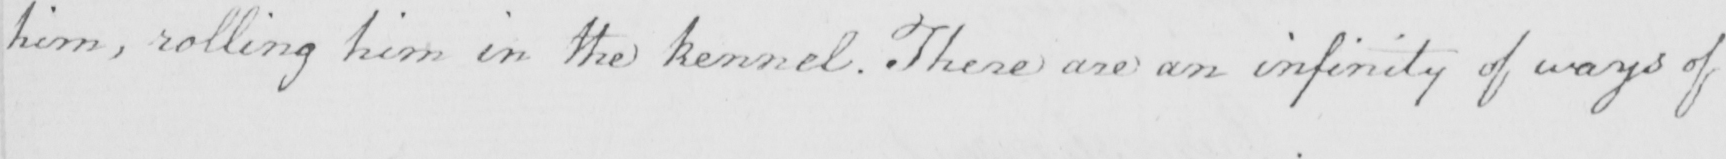Transcribe the text shown in this historical manuscript line. him , rolling him in the kennel . There are an infinity of ways of 